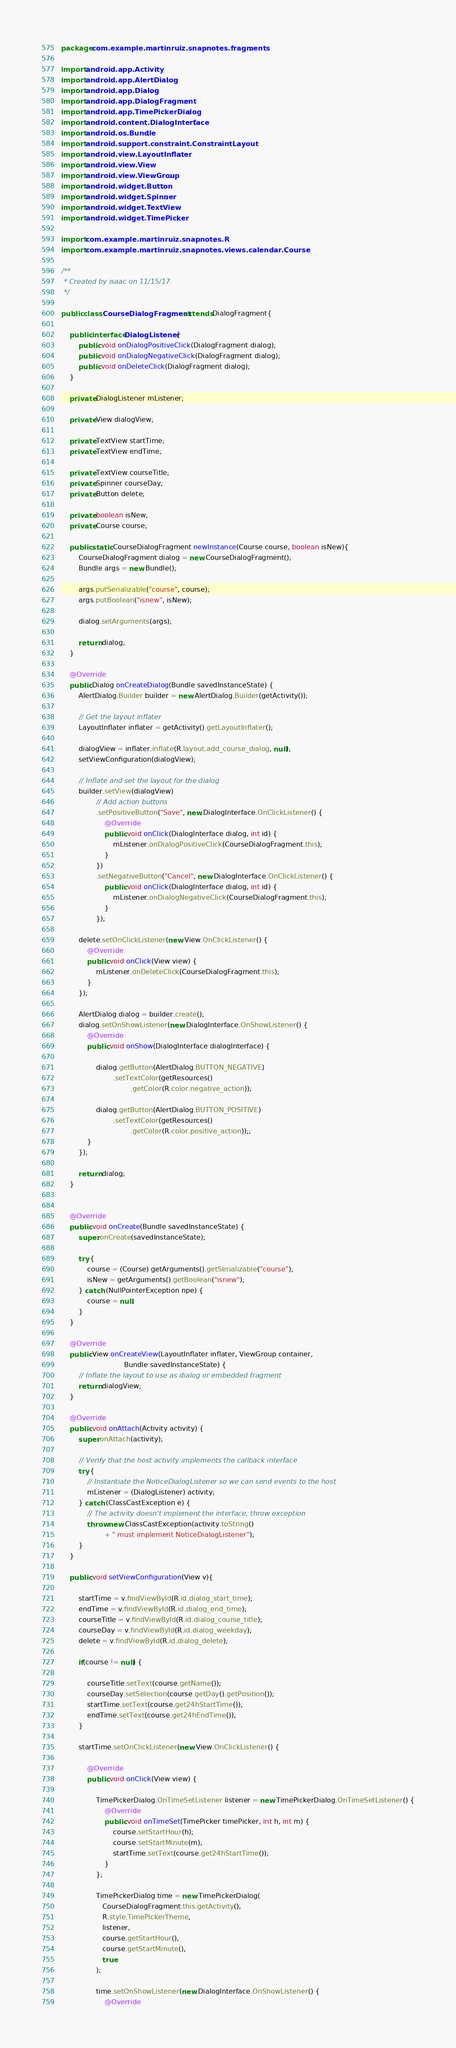<code> <loc_0><loc_0><loc_500><loc_500><_Java_>package com.example.martinruiz.snapnotes.fragments;

import android.app.Activity;
import android.app.AlertDialog;
import android.app.Dialog;
import android.app.DialogFragment;
import android.app.TimePickerDialog;
import android.content.DialogInterface;
import android.os.Bundle;
import android.support.constraint.ConstraintLayout;
import android.view.LayoutInflater;
import android.view.View;
import android.view.ViewGroup;
import android.widget.Button;
import android.widget.Spinner;
import android.widget.TextView;
import android.widget.TimePicker;

import com.example.martinruiz.snapnotes.R;
import com.example.martinruiz.snapnotes.views.calendar.Course;

/**
 * Created by isaac on 11/15/17.
 */

public class CourseDialogFragment extends DialogFragment{

    public interface DialogListener {
        public void onDialogPositiveClick(DialogFragment dialog);
        public void onDialogNegativeClick(DialogFragment dialog);
        public void onDeleteClick(DialogFragment dialog);
    }

    private DialogListener mListener;

    private View dialogView;

    private TextView startTime;
    private TextView endTime;

    private TextView courseTitle;
    private Spinner courseDay;
    private Button delete;

    private boolean isNew;
    private Course course;

    public static CourseDialogFragment newInstance(Course course, boolean isNew){
        CourseDialogFragment dialog = new CourseDialogFragment();
        Bundle args = new Bundle();

        args.putSerializable("course", course);
        args.putBoolean("isnew", isNew);

        dialog.setArguments(args);

        return dialog;
    }

    @Override
    public Dialog onCreateDialog(Bundle savedInstanceState) {
        AlertDialog.Builder builder = new AlertDialog.Builder(getActivity());

        // Get the layout inflater
        LayoutInflater inflater = getActivity().getLayoutInflater();

        dialogView = inflater.inflate(R.layout.add_course_dialog, null);
        setViewConfiguration(dialogView);

        // Inflate and set the layout for the dialog
        builder.setView(dialogView)
                // Add action buttons
                .setPositiveButton("Save", new DialogInterface.OnClickListener() {
                    @Override
                    public void onClick(DialogInterface dialog, int id) {
                        mListener.onDialogPositiveClick(CourseDialogFragment.this);
                    }
                })
                .setNegativeButton("Cancel", new DialogInterface.OnClickListener() {
                    public void onClick(DialogInterface dialog, int id) {
                        mListener.onDialogNegativeClick(CourseDialogFragment.this);
                    }
                });

        delete.setOnClickListener(new View.OnClickListener() {
            @Override
            public void onClick(View view) {
                mListener.onDeleteClick(CourseDialogFragment.this);
            }
        });

        AlertDialog dialog = builder.create();
        dialog.setOnShowListener(new DialogInterface.OnShowListener() {
            @Override
            public void onShow(DialogInterface dialogInterface) {

                dialog.getButton(AlertDialog.BUTTON_NEGATIVE)
                        .setTextColor(getResources()
                                .getColor(R.color.negative_action));

                dialog.getButton(AlertDialog.BUTTON_POSITIVE)
                        .setTextColor(getResources()
                                .getColor(R.color.positive_action));;
            }
        });

        return dialog;
    }


    @Override
    public void onCreate(Bundle savedInstanceState) {
        super.onCreate(savedInstanceState);

        try {
            course = (Course) getArguments().getSerializable("course");
            isNew = getArguments().getBoolean("isnew");
        } catch (NullPointerException npe) {
            course = null;
        }
    }

    @Override
    public View onCreateView(LayoutInflater inflater, ViewGroup container,
                             Bundle savedInstanceState) {
        // Inflate the layout to use as dialog or embedded fragment
        return dialogView;
    }

    @Override
    public void onAttach(Activity activity) {
        super.onAttach(activity);

        // Verify that the host activity implements the callback interface
        try {
            // Instantiate the NoticeDialogListener so we can send events to the host
            mListener = (DialogListener) activity;
        } catch (ClassCastException e) {
            // The activity doesn't implement the interface, throw exception
            throw new ClassCastException(activity.toString()
                    + " must implement NoticeDialogListener");
        }
    }

    public void setViewConfiguration(View v){

        startTime = v.findViewById(R.id.dialog_start_time);
        endTime = v.findViewById(R.id.dialog_end_time);
        courseTitle = v.findViewById(R.id.dialog_course_title);
        courseDay = v.findViewById(R.id.dialog_weekday);
        delete = v.findViewById(R.id.dialog_delete);

        if(course != null) {

            courseTitle.setText(course.getName());
            courseDay.setSelection(course.getDay().getPosition());
            startTime.setText(course.get24hStartTime());
            endTime.setText(course.get24hEndTime());
        }

        startTime.setOnClickListener(new View.OnClickListener() {

            @Override
            public void onClick(View view) {

                TimePickerDialog.OnTimeSetListener listener = new TimePickerDialog.OnTimeSetListener() {
                    @Override
                    public void onTimeSet(TimePicker timePicker, int h, int m) {
                        course.setStartHour(h);
                        course.setStartMinute(m);
                        startTime.setText(course.get24hStartTime());
                    }
                };

                TimePickerDialog time = new TimePickerDialog(
                   CourseDialogFragment.this.getActivity(),
                   R.style.TimePickerTheme,
                   listener,
                   course.getStartHour(),
                   course.getStartMinute(),
                   true
                );

                time.setOnShowListener(new DialogInterface.OnShowListener() {
                    @Override</code> 